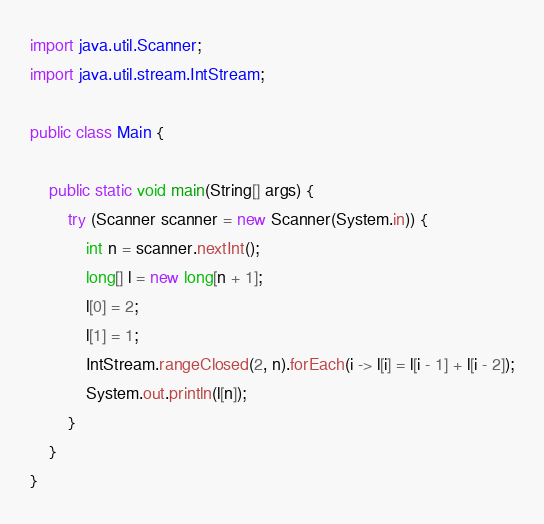<code> <loc_0><loc_0><loc_500><loc_500><_Java_>import java.util.Scanner;
import java.util.stream.IntStream;

public class Main {

	public static void main(String[] args) {
		try (Scanner scanner = new Scanner(System.in)) {
			int n = scanner.nextInt();
			long[] l = new long[n + 1];
			l[0] = 2;
			l[1] = 1;
			IntStream.rangeClosed(2, n).forEach(i -> l[i] = l[i - 1] + l[i - 2]);
			System.out.println(l[n]);
		}
	}
}
</code> 